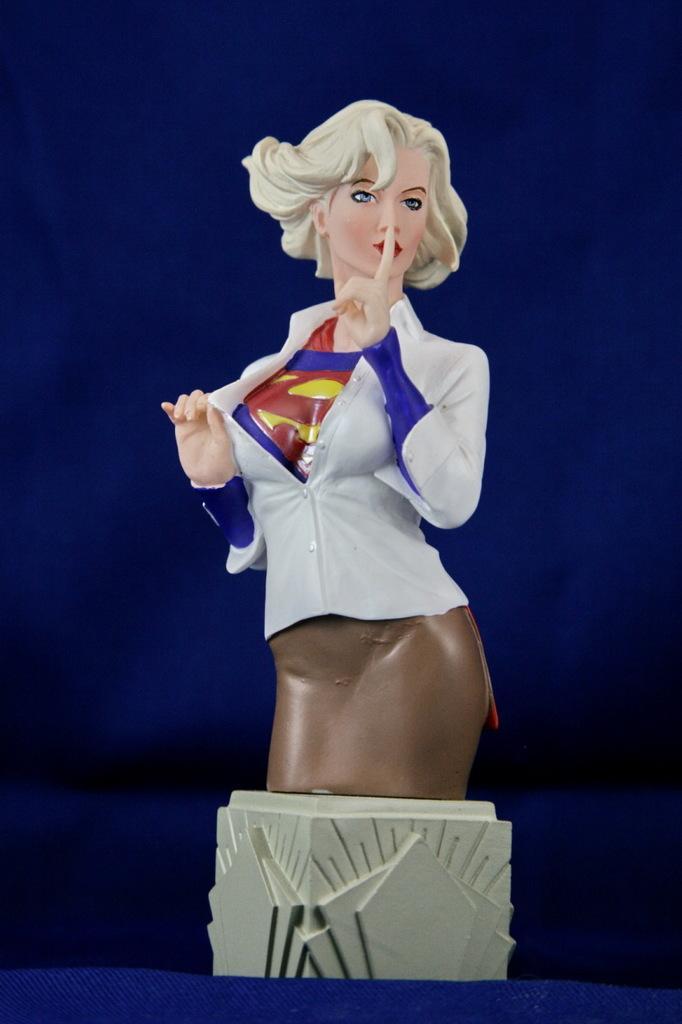In one or two sentences, can you explain what this image depicts? In the picture I can see a toy of a woman placed on an object and the background is in blue color. 